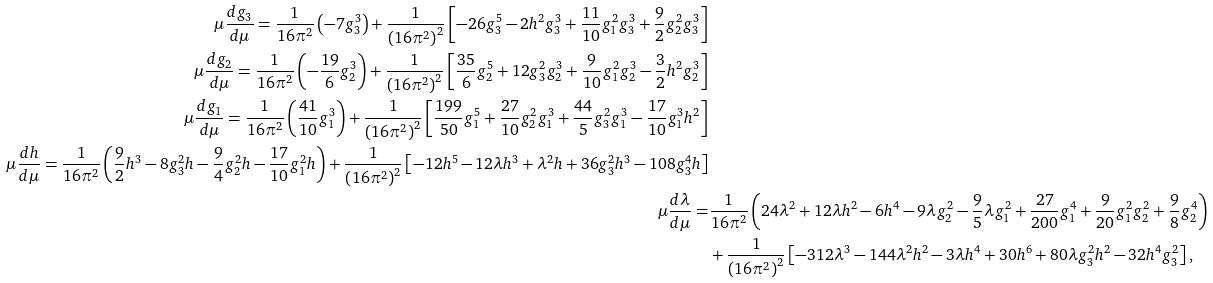<formula> <loc_0><loc_0><loc_500><loc_500>\mu \frac { d g _ { 3 } } { d \mu } = \frac { 1 } { 1 6 \pi ^ { 2 } } \left ( - 7 g _ { 3 } ^ { 3 } \right ) + \frac { 1 } { \left ( 1 6 \pi ^ { 2 } \right ) ^ { 2 } } \left [ - 2 6 g _ { 3 } ^ { 5 } - 2 h ^ { 2 } g _ { 3 } ^ { 3 } + \frac { 1 1 } { 1 0 } g _ { 1 } ^ { 2 } g _ { 3 } ^ { 3 } + \frac { 9 } { 2 } g _ { 2 } ^ { 2 } g _ { 3 } ^ { 3 } \right ] \\ \mu \frac { d g _ { 2 } } { d \mu } = \frac { 1 } { 1 6 \pi ^ { 2 } } \left ( - \frac { 1 9 } { 6 } g _ { 2 } ^ { 3 } \right ) + \frac { 1 } { \left ( 1 6 \pi ^ { 2 } \right ) ^ { 2 } } \left [ \frac { 3 5 } { 6 } g _ { 2 } ^ { 5 } + 1 2 g _ { 3 } ^ { 2 } g _ { 2 } ^ { 3 } + \frac { 9 } { 1 0 } g _ { 1 } ^ { 2 } g _ { 2 } ^ { 3 } - \frac { 3 } { 2 } h ^ { 2 } g _ { 2 } ^ { 3 } \right ] \\ \mu \frac { d g _ { 1 } } { d \mu } = \frac { 1 } { 1 6 \pi ^ { 2 } } \left ( \frac { 4 1 } { 1 0 } g _ { 1 } ^ { 3 } \right ) + \frac { 1 } { \left ( 1 6 \pi ^ { 2 } \right ) ^ { 2 } } \left [ \frac { 1 9 9 } { 5 0 } g _ { 1 } ^ { 5 } + \frac { 2 7 } { 1 0 } g _ { 2 } ^ { 2 } g _ { 1 } ^ { 3 } + \frac { 4 4 } { 5 } g _ { 3 } ^ { 2 } g _ { 1 } ^ { 3 } - \frac { 1 7 } { 1 0 } g _ { 1 } ^ { 3 } h ^ { 2 } \right ] \\ \mu \frac { d h } { d \mu } = \frac { 1 } { 1 6 \pi ^ { 2 } } \left ( \frac { 9 } { 2 } h ^ { 3 } - 8 g _ { 3 } ^ { 2 } h - \frac { 9 } { 4 } g _ { 2 } ^ { 2 } h - \frac { 1 7 } { 1 0 } g _ { 1 } ^ { 2 } h \right ) + \frac { 1 } { \left ( 1 6 \pi ^ { 2 } \right ) ^ { 2 } } \left [ - 1 2 h ^ { 5 } - 1 2 \lambda h ^ { 3 } + \lambda ^ { 2 } h + 3 6 g _ { 3 } ^ { 2 } h ^ { 3 } - 1 0 8 g _ { 3 } ^ { 4 } h \right ] \\ \mu \frac { d \lambda } { d \mu } = & \frac { 1 } { 1 6 \pi ^ { 2 } } \left ( 2 4 \lambda ^ { 2 } + 1 2 \lambda h ^ { 2 } - 6 h ^ { 4 } - 9 \lambda g _ { 2 } ^ { 2 } - \frac { 9 } { 5 } \lambda g _ { 1 } ^ { 2 } + \frac { 2 7 } { 2 0 0 } g _ { 1 } ^ { 4 } + \frac { 9 } { 2 0 } g _ { 1 } ^ { 2 } g _ { 2 } ^ { 2 } + \frac { 9 } { 8 } g _ { 2 } ^ { 4 } \right ) \\ & + \frac { 1 } { \left ( 1 6 \pi ^ { 2 } \right ) ^ { 2 } } \left [ - 3 1 2 \lambda ^ { 3 } - 1 4 4 \lambda ^ { 2 } h ^ { 2 } - 3 \lambda h ^ { 4 } + 3 0 h ^ { 6 } + 8 0 \lambda g _ { 3 } ^ { 2 } h ^ { 2 } - 3 2 h ^ { 4 } g _ { 3 } ^ { 2 } \right ] ,</formula> 